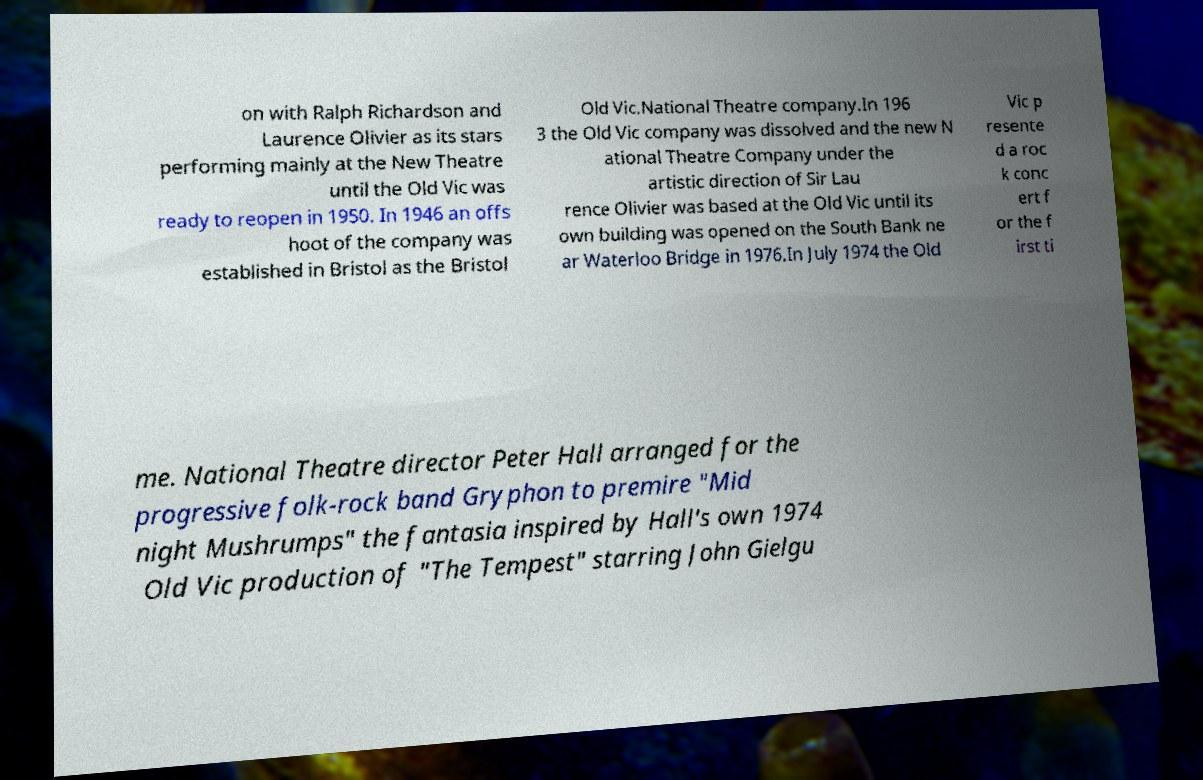There's text embedded in this image that I need extracted. Can you transcribe it verbatim? on with Ralph Richardson and Laurence Olivier as its stars performing mainly at the New Theatre until the Old Vic was ready to reopen in 1950. In 1946 an offs hoot of the company was established in Bristol as the Bristol Old Vic.National Theatre company.In 196 3 the Old Vic company was dissolved and the new N ational Theatre Company under the artistic direction of Sir Lau rence Olivier was based at the Old Vic until its own building was opened on the South Bank ne ar Waterloo Bridge in 1976.In July 1974 the Old Vic p resente d a roc k conc ert f or the f irst ti me. National Theatre director Peter Hall arranged for the progressive folk-rock band Gryphon to premire "Mid night Mushrumps" the fantasia inspired by Hall's own 1974 Old Vic production of "The Tempest" starring John Gielgu 